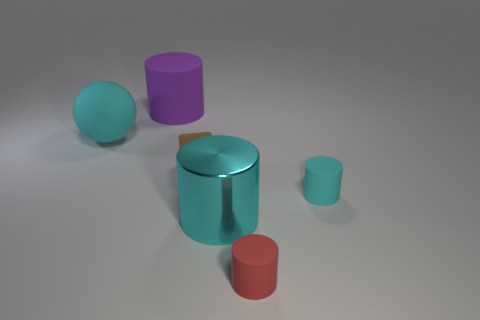What is the size of the matte object that is both behind the cyan metal cylinder and right of the big cyan metal cylinder?
Make the answer very short. Small. What is the shape of the tiny brown thing?
Make the answer very short. Cube. What number of large purple objects are the same shape as the big cyan metal thing?
Offer a very short reply. 1. Are there fewer metal things left of the purple cylinder than brown objects that are on the right side of the red cylinder?
Ensure brevity in your answer.  No. How many tiny brown cubes are on the left side of the big cyan object that is on the right side of the brown cube?
Offer a terse response. 1. Are there any brown objects?
Your response must be concise. Yes. Is there a purple object made of the same material as the block?
Provide a succinct answer. Yes. Is the number of small blocks that are on the right side of the big cyan metal cylinder greater than the number of big purple cylinders in front of the red thing?
Provide a short and direct response. No. Does the purple rubber thing have the same size as the brown thing?
Your answer should be compact. No. There is a big object that is to the right of the large cylinder to the left of the cyan metal cylinder; what is its color?
Give a very brief answer. Cyan. 